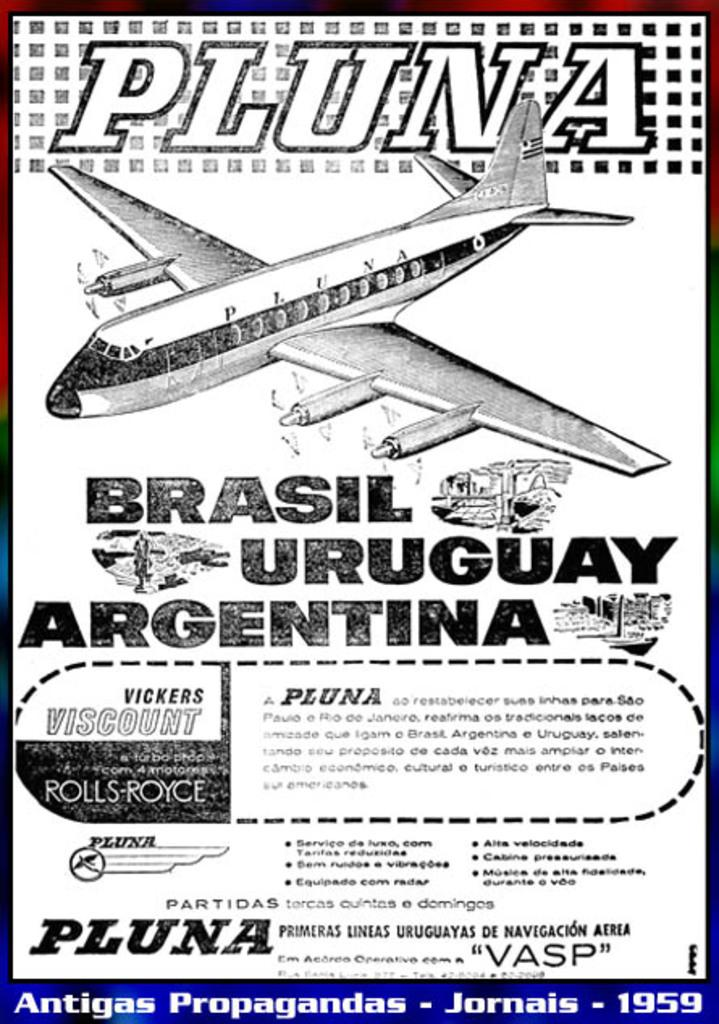What type of visual is the image? The image is a poster. What is the main subject of the poster? There is an airplane depicted on the poster. Are there any words or phrases on the poster? Yes, there is text present on the poster. What type of support can be seen holding up the airplane in the image? There is no support holding up the airplane in the image; it is depicted as a standalone object. Is there a judge present in the image? There is no judge depicted in the image; it features an airplane and text. 